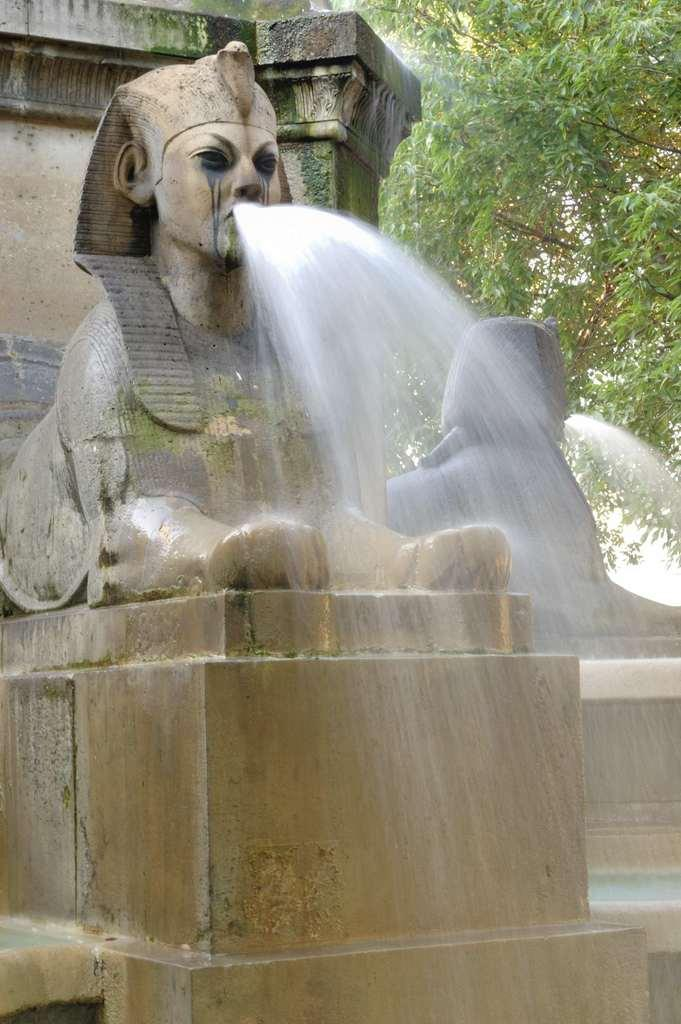What can be seen in the foreground of the picture? There are sculptures and a fountain in the foreground of the picture. What type of objects are the sculptures? The provided facts do not specify the type of sculptures. What can be seen in the background of the picture? There are trees in the background of the picture. What arithmetic problem is being solved by the worm in the picture? There is no worm present in the picture, and therefore no arithmetic problem can be observed. 